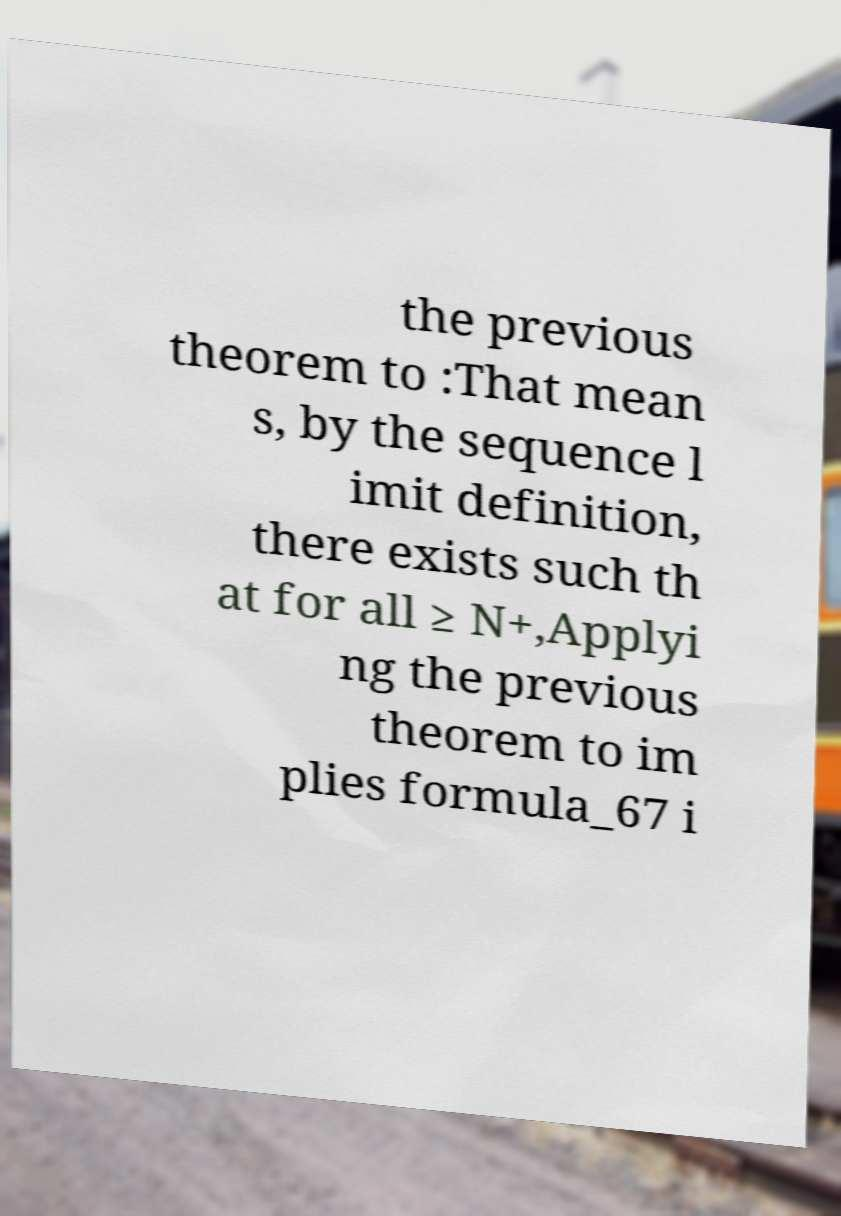Please read and relay the text visible in this image. What does it say? the previous theorem to :That mean s, by the sequence l imit definition, there exists such th at for all ≥ N+,Applyi ng the previous theorem to im plies formula_67 i 